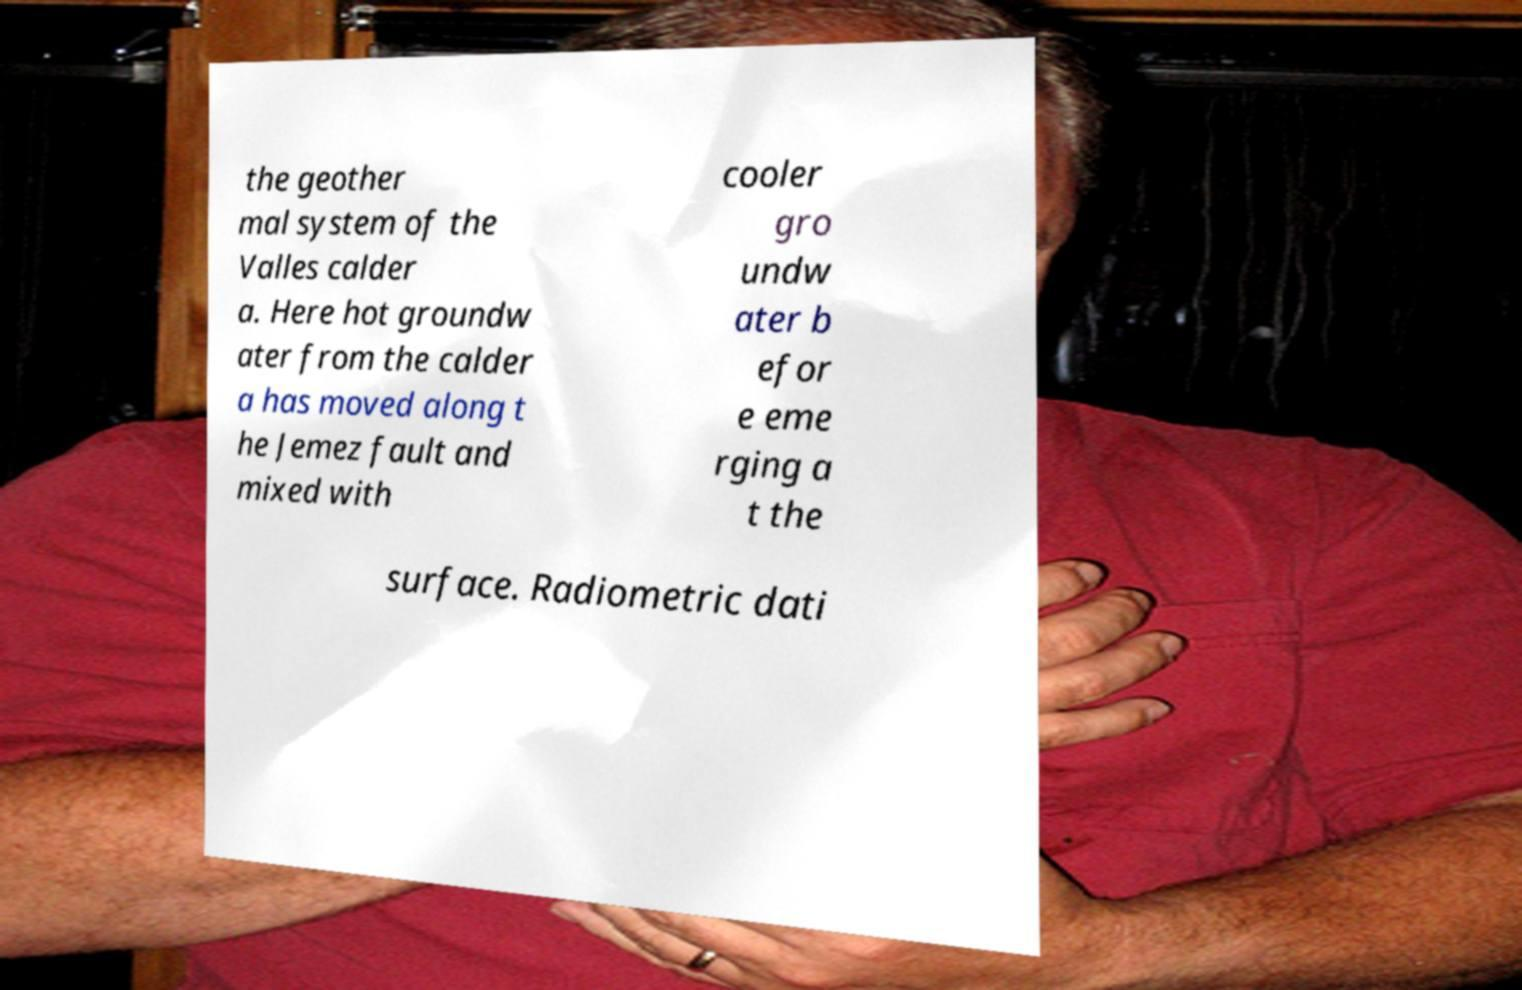Can you accurately transcribe the text from the provided image for me? the geother mal system of the Valles calder a. Here hot groundw ater from the calder a has moved along t he Jemez fault and mixed with cooler gro undw ater b efor e eme rging a t the surface. Radiometric dati 